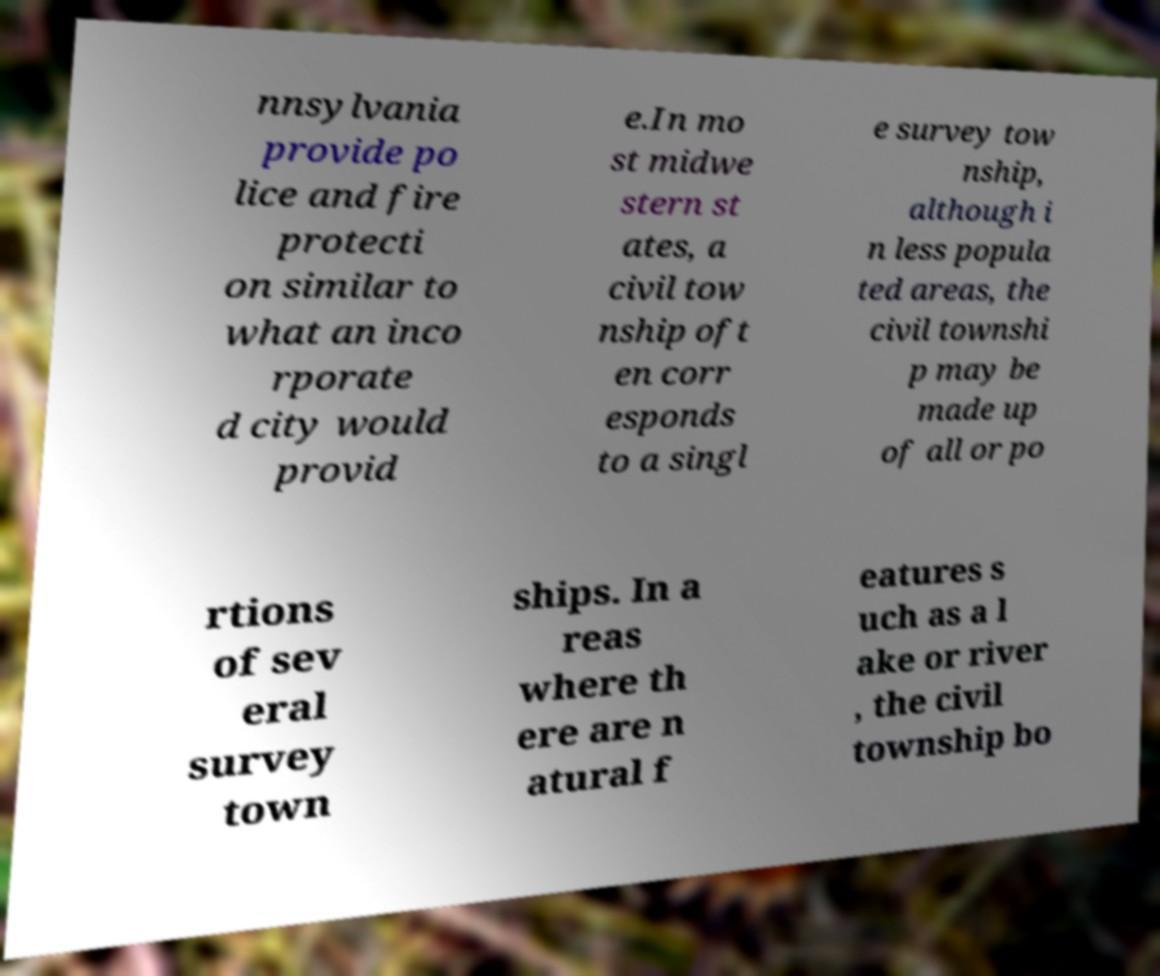Could you extract and type out the text from this image? nnsylvania provide po lice and fire protecti on similar to what an inco rporate d city would provid e.In mo st midwe stern st ates, a civil tow nship oft en corr esponds to a singl e survey tow nship, although i n less popula ted areas, the civil townshi p may be made up of all or po rtions of sev eral survey town ships. In a reas where th ere are n atural f eatures s uch as a l ake or river , the civil township bo 